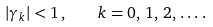Convert formula to latex. <formula><loc_0><loc_0><loc_500><loc_500>| \gamma _ { k } | < 1 \, , \quad k = 0 , \, 1 , \, 2 , \, \dots \, .</formula> 